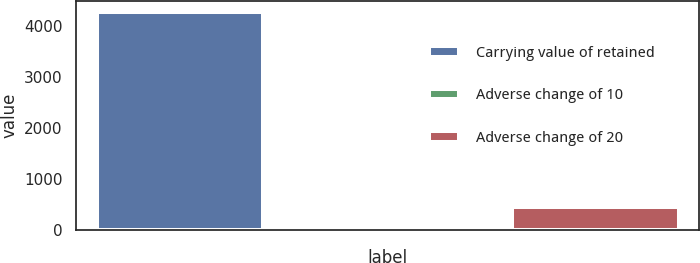Convert chart to OTSL. <chart><loc_0><loc_0><loc_500><loc_500><bar_chart><fcel>Carrying value of retained<fcel>Adverse change of 10<fcel>Adverse change of 20<nl><fcel>4261<fcel>30<fcel>453.1<nl></chart> 